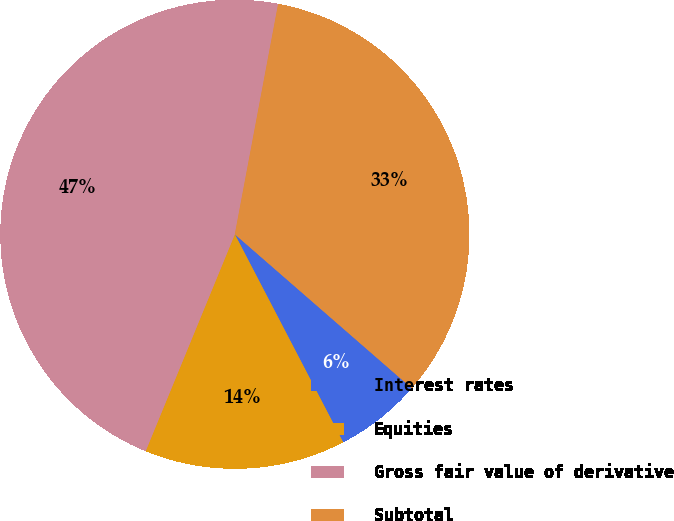Convert chart. <chart><loc_0><loc_0><loc_500><loc_500><pie_chart><fcel>Interest rates<fcel>Equities<fcel>Gross fair value of derivative<fcel>Subtotal<nl><fcel>5.96%<fcel>13.85%<fcel>46.75%<fcel>33.44%<nl></chart> 